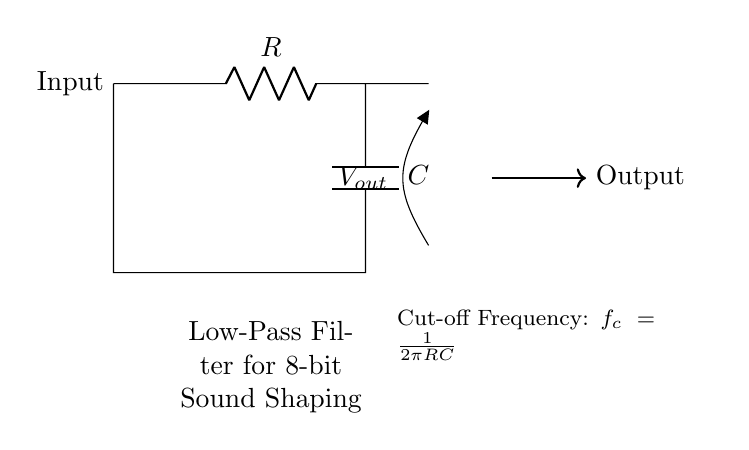What are the components in this circuit? The circuit contains a resistor and a capacitor as its main components. The resistor is denoted by R and the capacitor by C in the diagram.
Answer: Resistor and Capacitor What is the function of the low-pass filter? The low-pass filter smooths out the high-frequency components of the signal, allowing only the lower frequencies to pass through, effectively shaping the timbre of 8-bit sounds.
Answer: Smooths high frequencies What is the cut-off frequency formula represented in the circuit? The cut-off frequency formula is written as \( f_c = \frac{1}{2\pi RC} \). This indicates how the frequency response is determined by the values of the resistor and capacitor.
Answer: \( \frac{1}{2\pi RC} \) How can altering the resistor value affect the circuit? Increasing the resistance value (\( R \)) will lower the cut-off frequency, allowing fewer high frequencies to pass through, whereas decreasing it will raise the cut-off frequency. This changes the signal's timbre.
Answer: It lowers the cut-off frequency What type of filter is shown in the circuit? The circuit diagram illustrates a low-pass filter, as indicated by the designation and function of the components, which allows signals lower than the cut-off frequency to pass.
Answer: Low-pass filter 